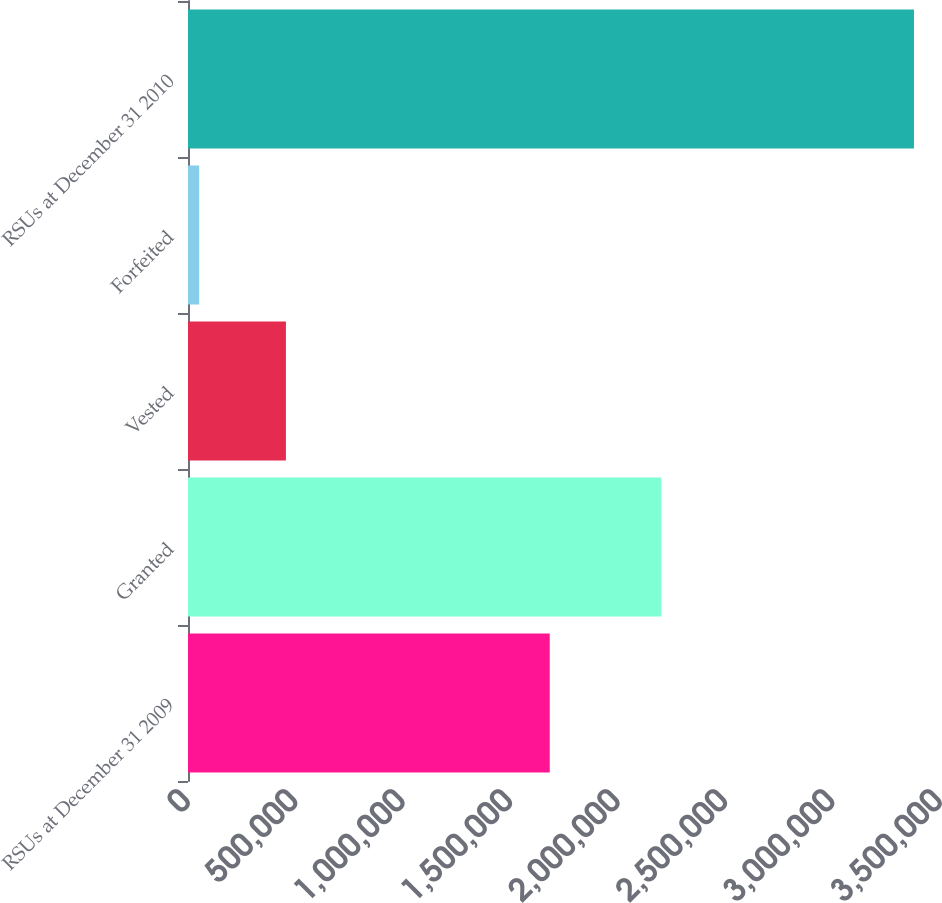<chart> <loc_0><loc_0><loc_500><loc_500><bar_chart><fcel>RSUs at December 31 2009<fcel>Granted<fcel>Vested<fcel>Forfeited<fcel>RSUs at December 31 2010<nl><fcel>1.68361e+06<fcel>2.20306e+06<fcel>455765<fcel>52065<fcel>3.37884e+06<nl></chart> 